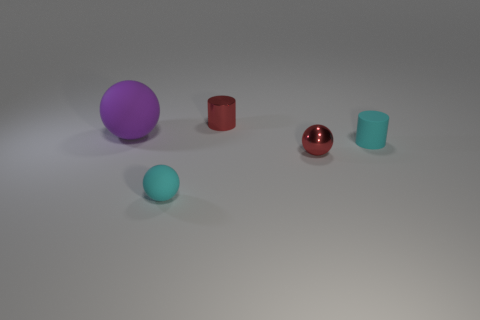Is there any other thing that is the same size as the purple matte ball?
Provide a short and direct response. No. The big rubber thing has what shape?
Offer a terse response. Sphere. The tiny sphere that is on the right side of the matte ball that is right of the purple rubber object is made of what material?
Offer a terse response. Metal. How many other objects are there of the same material as the small cyan ball?
Your response must be concise. 2. What material is the cyan ball that is the same size as the metallic cylinder?
Your response must be concise. Rubber. Is the number of small cyan matte objects that are to the right of the tiny cyan ball greater than the number of small cyan spheres on the right side of the tiny red cylinder?
Provide a succinct answer. Yes. Is there another red object that has the same shape as the large object?
Your answer should be compact. Yes. The cyan object that is the same size as the cyan cylinder is what shape?
Offer a very short reply. Sphere. What shape is the red metal thing behind the big purple ball?
Offer a very short reply. Cylinder. Are there fewer large spheres on the left side of the purple object than cyan matte spheres left of the tiny cyan matte cylinder?
Ensure brevity in your answer.  Yes. 